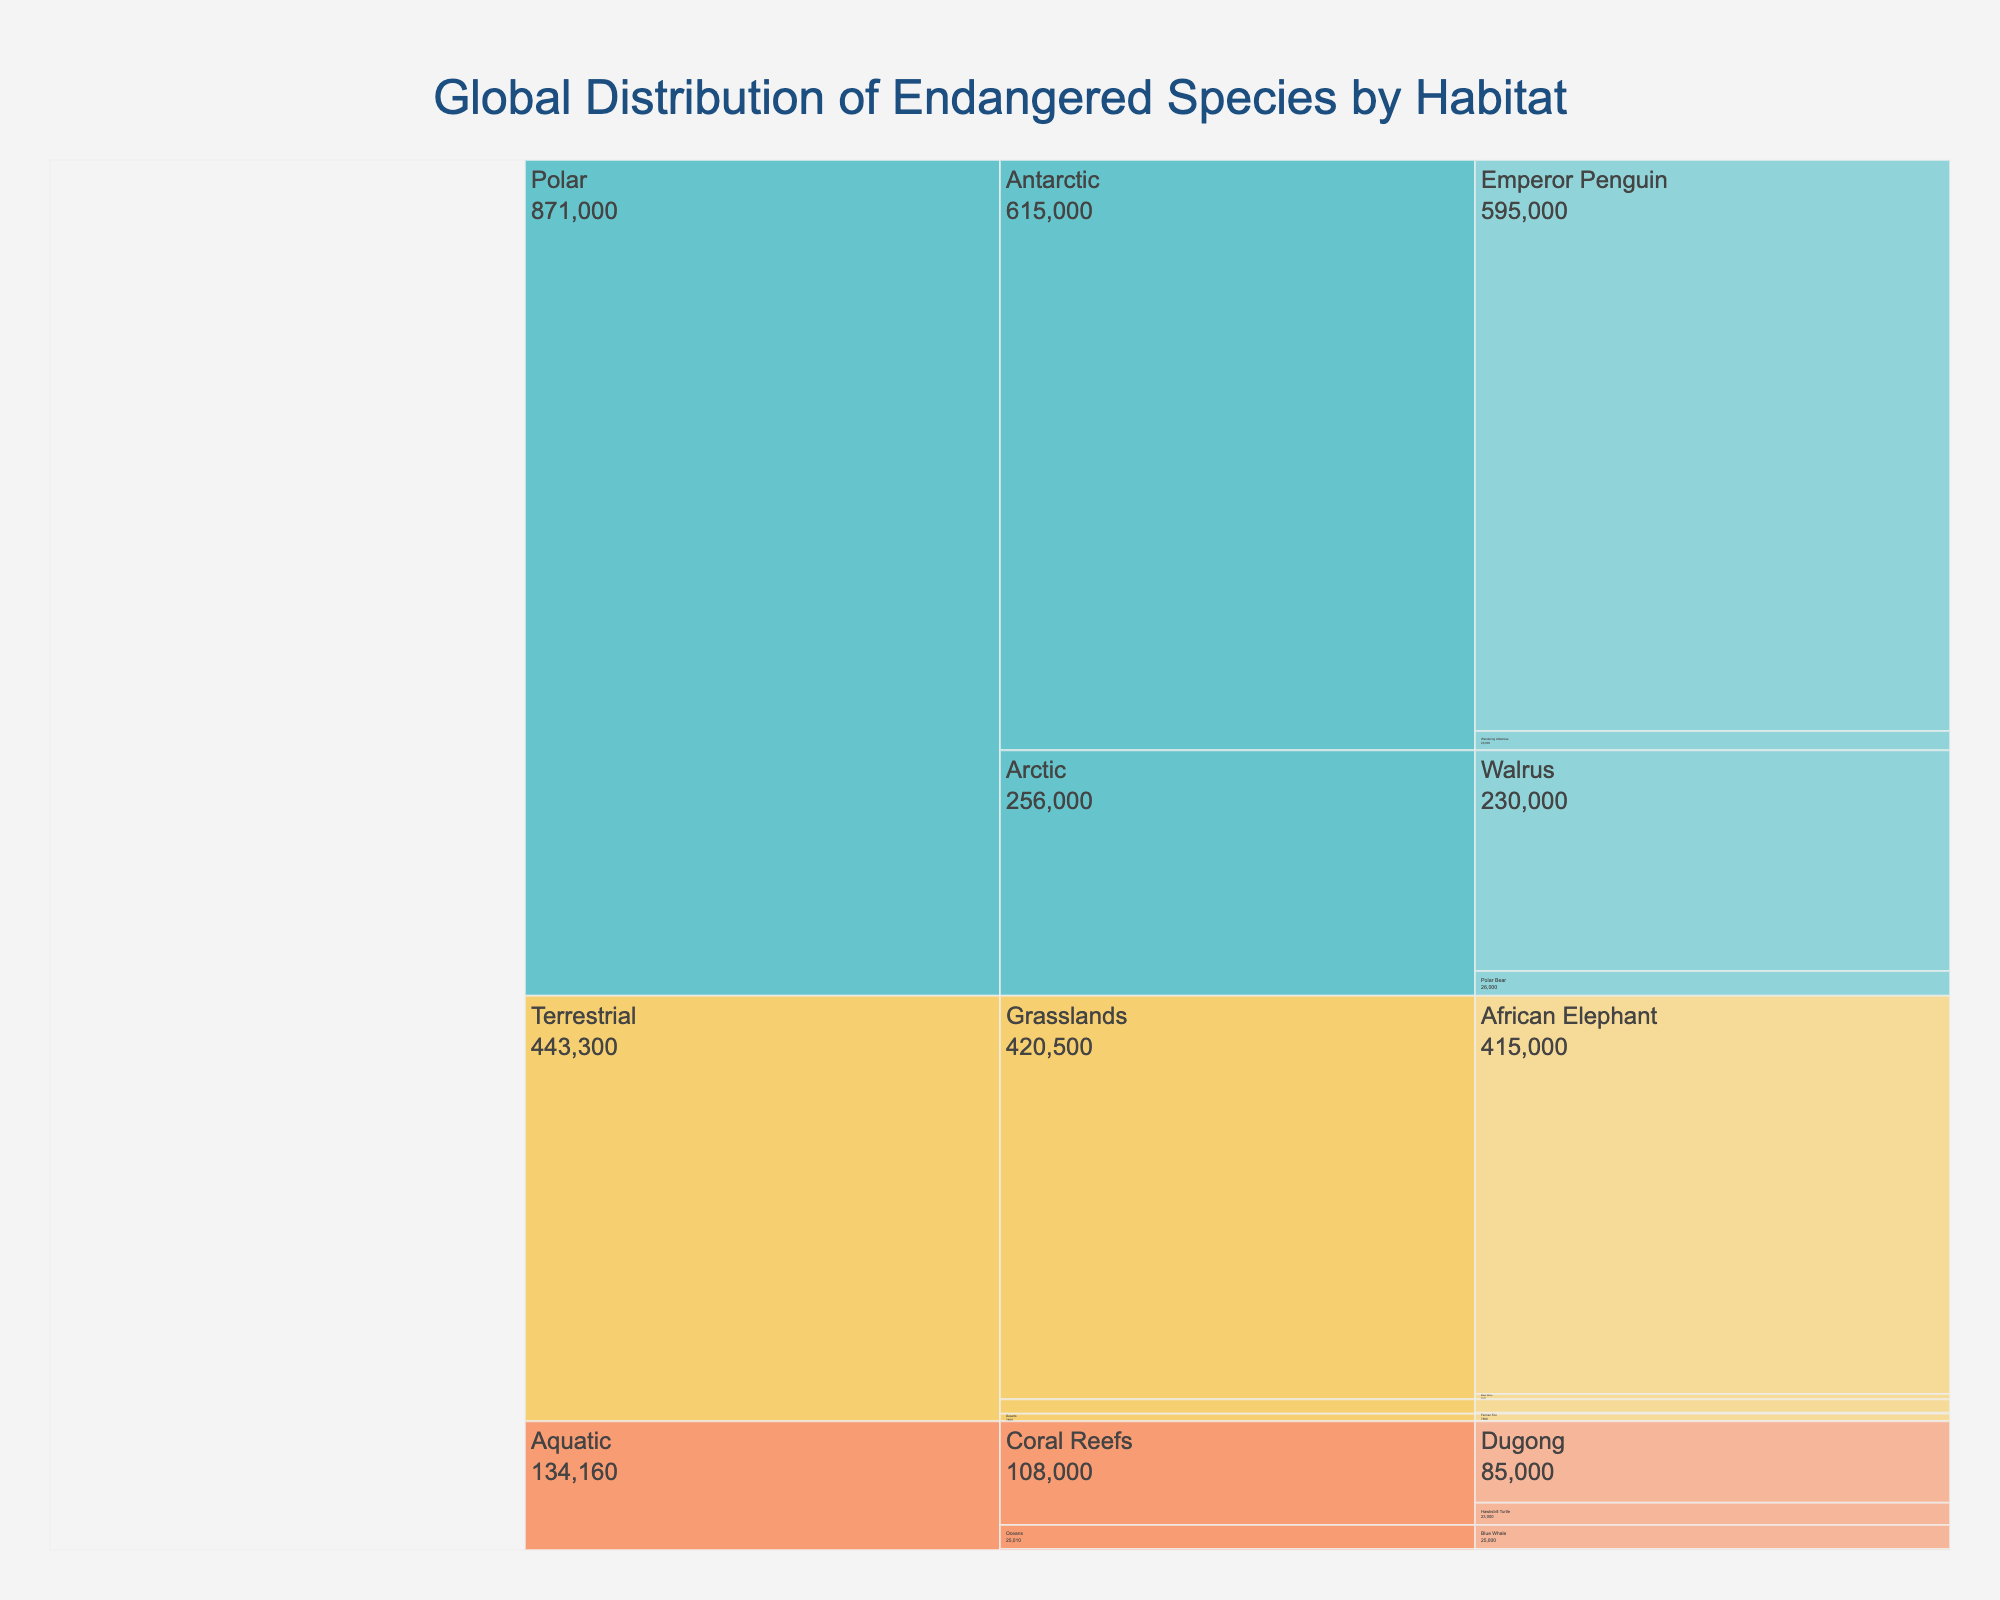What is the overall title of the figure? The title is always found at the top of the figure, typically centered. In this case, it reads "Global Distribution of Endangered Species by Habitat."
Answer: Global Distribution of Endangered Species by Habitat Which habitat in the Terrestrial category has the highest number of endangered species? Within the Terrestrial category, the chart shows Forests, Grasslands, and Deserts. By looking at the aggregated numbers for each, you can see that Grasslands (with African Elephants and Black Rhinos) have the highest count.
Answer: Grasslands How many total endangered species are there in the Polar category? Summing up the counts of endangered species in the Arctic and Antarctic habitats within the Polar category: Polar Bear (26,000), Walrus (230,000), Emperor Penguin (595,000), and Wandering Albatross (20,000). The total is 26,000 + 230,000 + 595,000 + 20,000 = 871,000.
Answer: 871,000 Which animal has the smallest population in the Aquatic category? Within the Aquatic category, looking at the counts for Coral Reefs, Rivers, and Oceans, the Vaquita in the Oceans has the smallest population with just 10 individuals.
Answer: Vaquita Compare the number of endangered species in Coral Reefs to those in Oceans. Which has a higher count and by how much? Summing up the endangered species in Coral Reefs (Hawksbill Turtle: 23,000 and Dugong: 85,000) gives 108,000. In Oceans, the Blue Whale (25,000) and Vaquita (10) sum to 25,010. Coral Reefs have 108,000 - 25,010 = 82,990 more endangered species.
Answer: Coral Reefs, 82,990 What is the total number of endangered species in Forest habitats? Adding the counts of the Sumatran Orangutan (14,000) and Mountain Gorilla (1,000), the total number of endangered species in Forest habitats is 14,000 + 1,000 = 15,000.
Answer: 15,000 Identify the species with the highest count in the figure and its habitat. The highest count can be found in the Polar category under Antarctic habitat with the Emperor Penguin having a count of 595,000.
Answer: Emperor Penguin, Antarctic 